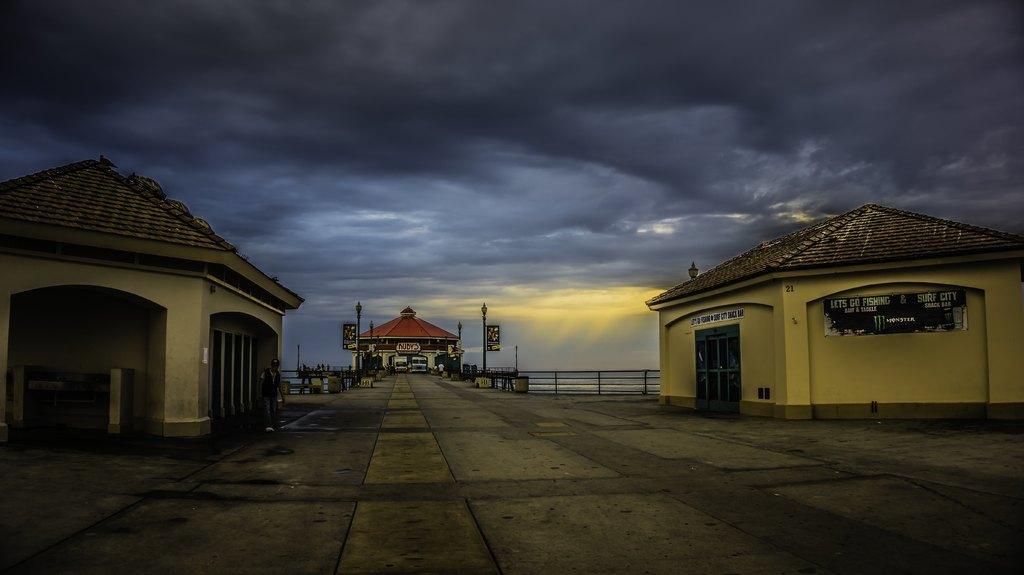How would you summarize this image in a sentence or two? In this image we can see some houses, a person, vehicles and other objects. At the top of the image there is the sky. At the bottom of the image there is the road. 